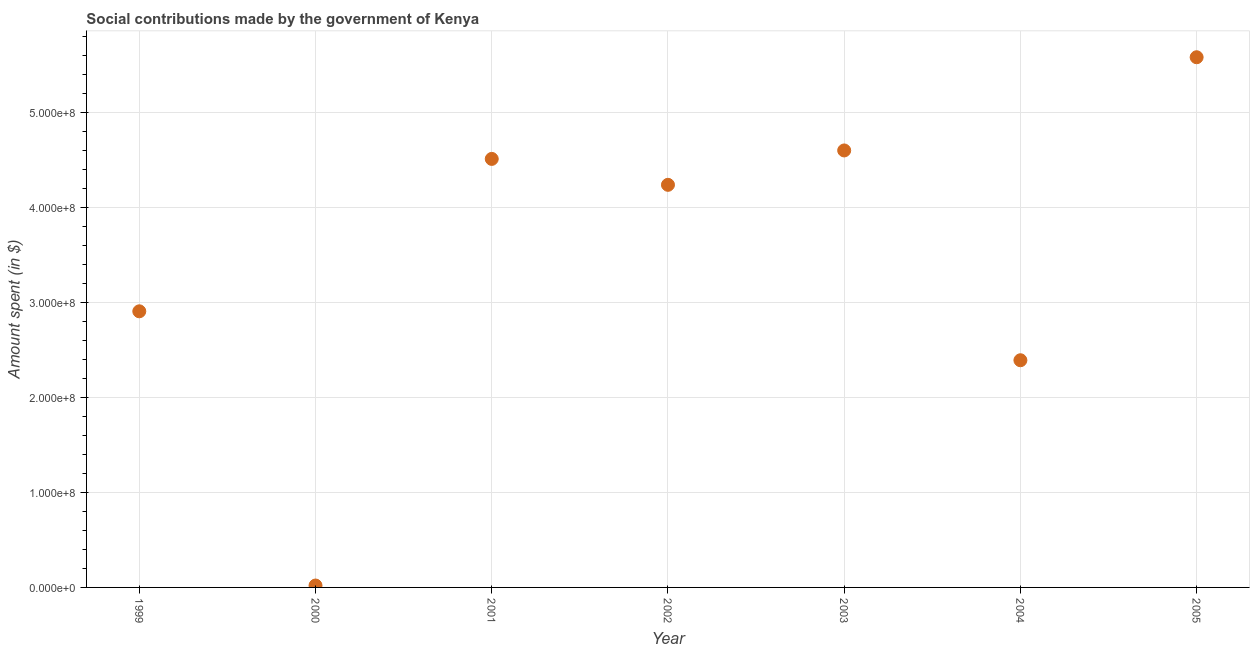What is the amount spent in making social contributions in 2005?
Your answer should be very brief. 5.58e+08. Across all years, what is the maximum amount spent in making social contributions?
Provide a succinct answer. 5.58e+08. Across all years, what is the minimum amount spent in making social contributions?
Make the answer very short. 2.00e+06. In which year was the amount spent in making social contributions maximum?
Your answer should be compact. 2005. What is the sum of the amount spent in making social contributions?
Give a very brief answer. 2.42e+09. What is the difference between the amount spent in making social contributions in 2001 and 2002?
Ensure brevity in your answer.  2.73e+07. What is the average amount spent in making social contributions per year?
Offer a very short reply. 3.46e+08. What is the median amount spent in making social contributions?
Make the answer very short. 4.24e+08. In how many years, is the amount spent in making social contributions greater than 140000000 $?
Make the answer very short. 6. Do a majority of the years between 2005 and 1999 (inclusive) have amount spent in making social contributions greater than 560000000 $?
Offer a terse response. Yes. What is the ratio of the amount spent in making social contributions in 2003 to that in 2004?
Make the answer very short. 1.92. Is the amount spent in making social contributions in 2001 less than that in 2002?
Keep it short and to the point. No. Is the difference between the amount spent in making social contributions in 1999 and 2005 greater than the difference between any two years?
Provide a succinct answer. No. What is the difference between the highest and the second highest amount spent in making social contributions?
Keep it short and to the point. 9.81e+07. What is the difference between the highest and the lowest amount spent in making social contributions?
Your answer should be compact. 5.56e+08. In how many years, is the amount spent in making social contributions greater than the average amount spent in making social contributions taken over all years?
Give a very brief answer. 4. How many dotlines are there?
Offer a terse response. 1. How many years are there in the graph?
Keep it short and to the point. 7. What is the difference between two consecutive major ticks on the Y-axis?
Your response must be concise. 1.00e+08. Does the graph contain any zero values?
Offer a very short reply. No. What is the title of the graph?
Give a very brief answer. Social contributions made by the government of Kenya. What is the label or title of the X-axis?
Provide a short and direct response. Year. What is the label or title of the Y-axis?
Provide a succinct answer. Amount spent (in $). What is the Amount spent (in $) in 1999?
Give a very brief answer. 2.91e+08. What is the Amount spent (in $) in 2000?
Provide a short and direct response. 2.00e+06. What is the Amount spent (in $) in 2001?
Make the answer very short. 4.51e+08. What is the Amount spent (in $) in 2002?
Keep it short and to the point. 4.24e+08. What is the Amount spent (in $) in 2003?
Offer a terse response. 4.60e+08. What is the Amount spent (in $) in 2004?
Make the answer very short. 2.39e+08. What is the Amount spent (in $) in 2005?
Provide a short and direct response. 5.58e+08. What is the difference between the Amount spent (in $) in 1999 and 2000?
Ensure brevity in your answer.  2.89e+08. What is the difference between the Amount spent (in $) in 1999 and 2001?
Provide a short and direct response. -1.60e+08. What is the difference between the Amount spent (in $) in 1999 and 2002?
Make the answer very short. -1.33e+08. What is the difference between the Amount spent (in $) in 1999 and 2003?
Offer a very short reply. -1.69e+08. What is the difference between the Amount spent (in $) in 1999 and 2004?
Your response must be concise. 5.15e+07. What is the difference between the Amount spent (in $) in 1999 and 2005?
Offer a terse response. -2.67e+08. What is the difference between the Amount spent (in $) in 2000 and 2001?
Ensure brevity in your answer.  -4.49e+08. What is the difference between the Amount spent (in $) in 2000 and 2002?
Give a very brief answer. -4.22e+08. What is the difference between the Amount spent (in $) in 2000 and 2003?
Ensure brevity in your answer.  -4.58e+08. What is the difference between the Amount spent (in $) in 2000 and 2004?
Provide a succinct answer. -2.37e+08. What is the difference between the Amount spent (in $) in 2000 and 2005?
Give a very brief answer. -5.56e+08. What is the difference between the Amount spent (in $) in 2001 and 2002?
Make the answer very short. 2.73e+07. What is the difference between the Amount spent (in $) in 2001 and 2003?
Provide a short and direct response. -8.90e+06. What is the difference between the Amount spent (in $) in 2001 and 2004?
Provide a short and direct response. 2.12e+08. What is the difference between the Amount spent (in $) in 2001 and 2005?
Your response must be concise. -1.07e+08. What is the difference between the Amount spent (in $) in 2002 and 2003?
Provide a short and direct response. -3.62e+07. What is the difference between the Amount spent (in $) in 2002 and 2004?
Your answer should be compact. 1.85e+08. What is the difference between the Amount spent (in $) in 2002 and 2005?
Your answer should be very brief. -1.34e+08. What is the difference between the Amount spent (in $) in 2003 and 2004?
Offer a very short reply. 2.21e+08. What is the difference between the Amount spent (in $) in 2003 and 2005?
Provide a succinct answer. -9.81e+07. What is the difference between the Amount spent (in $) in 2004 and 2005?
Provide a succinct answer. -3.19e+08. What is the ratio of the Amount spent (in $) in 1999 to that in 2000?
Offer a terse response. 145.3. What is the ratio of the Amount spent (in $) in 1999 to that in 2001?
Your response must be concise. 0.64. What is the ratio of the Amount spent (in $) in 1999 to that in 2002?
Your answer should be compact. 0.69. What is the ratio of the Amount spent (in $) in 1999 to that in 2003?
Your response must be concise. 0.63. What is the ratio of the Amount spent (in $) in 1999 to that in 2004?
Give a very brief answer. 1.22. What is the ratio of the Amount spent (in $) in 1999 to that in 2005?
Your answer should be very brief. 0.52. What is the ratio of the Amount spent (in $) in 2000 to that in 2001?
Offer a terse response. 0. What is the ratio of the Amount spent (in $) in 2000 to that in 2002?
Offer a very short reply. 0.01. What is the ratio of the Amount spent (in $) in 2000 to that in 2003?
Offer a terse response. 0. What is the ratio of the Amount spent (in $) in 2000 to that in 2004?
Your response must be concise. 0.01. What is the ratio of the Amount spent (in $) in 2000 to that in 2005?
Offer a very short reply. 0. What is the ratio of the Amount spent (in $) in 2001 to that in 2002?
Offer a terse response. 1.06. What is the ratio of the Amount spent (in $) in 2001 to that in 2004?
Your answer should be compact. 1.89. What is the ratio of the Amount spent (in $) in 2001 to that in 2005?
Provide a succinct answer. 0.81. What is the ratio of the Amount spent (in $) in 2002 to that in 2003?
Your answer should be compact. 0.92. What is the ratio of the Amount spent (in $) in 2002 to that in 2004?
Give a very brief answer. 1.77. What is the ratio of the Amount spent (in $) in 2002 to that in 2005?
Give a very brief answer. 0.76. What is the ratio of the Amount spent (in $) in 2003 to that in 2004?
Make the answer very short. 1.92. What is the ratio of the Amount spent (in $) in 2003 to that in 2005?
Make the answer very short. 0.82. What is the ratio of the Amount spent (in $) in 2004 to that in 2005?
Keep it short and to the point. 0.43. 